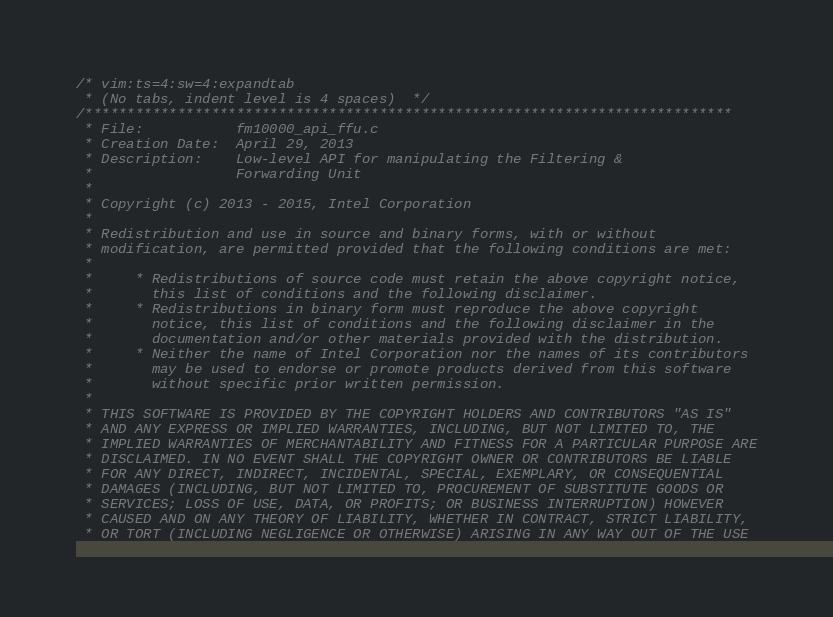<code> <loc_0><loc_0><loc_500><loc_500><_C_>/* vim:ts=4:sw=4:expandtab
 * (No tabs, indent level is 4 spaces)  */
/*****************************************************************************
 * File:           fm10000_api_ffu.c
 * Creation Date:  April 29, 2013
 * Description:    Low-level API for manipulating the Filtering &
 *                 Forwarding Unit
 *
 * Copyright (c) 2013 - 2015, Intel Corporation
 *
 * Redistribution and use in source and binary forms, with or without
 * modification, are permitted provided that the following conditions are met:
 *
 *     * Redistributions of source code must retain the above copyright notice,
 *       this list of conditions and the following disclaimer.
 *     * Redistributions in binary form must reproduce the above copyright
 *       notice, this list of conditions and the following disclaimer in the
 *       documentation and/or other materials provided with the distribution.
 *     * Neither the name of Intel Corporation nor the names of its contributors
 *       may be used to endorse or promote products derived from this software
 *       without specific prior written permission.
 *
 * THIS SOFTWARE IS PROVIDED BY THE COPYRIGHT HOLDERS AND CONTRIBUTORS "AS IS"
 * AND ANY EXPRESS OR IMPLIED WARRANTIES, INCLUDING, BUT NOT LIMITED TO, THE
 * IMPLIED WARRANTIES OF MERCHANTABILITY AND FITNESS FOR A PARTICULAR PURPOSE ARE
 * DISCLAIMED. IN NO EVENT SHALL THE COPYRIGHT OWNER OR CONTRIBUTORS BE LIABLE
 * FOR ANY DIRECT, INDIRECT, INCIDENTAL, SPECIAL, EXEMPLARY, OR CONSEQUENTIAL
 * DAMAGES (INCLUDING, BUT NOT LIMITED TO, PROCUREMENT OF SUBSTITUTE GOODS OR
 * SERVICES; LOSS OF USE, DATA, OR PROFITS; OR BUSINESS INTERRUPTION) HOWEVER
 * CAUSED AND ON ANY THEORY OF LIABILITY, WHETHER IN CONTRACT, STRICT LIABILITY,
 * OR TORT (INCLUDING NEGLIGENCE OR OTHERWISE) ARISING IN ANY WAY OUT OF THE USE</code> 